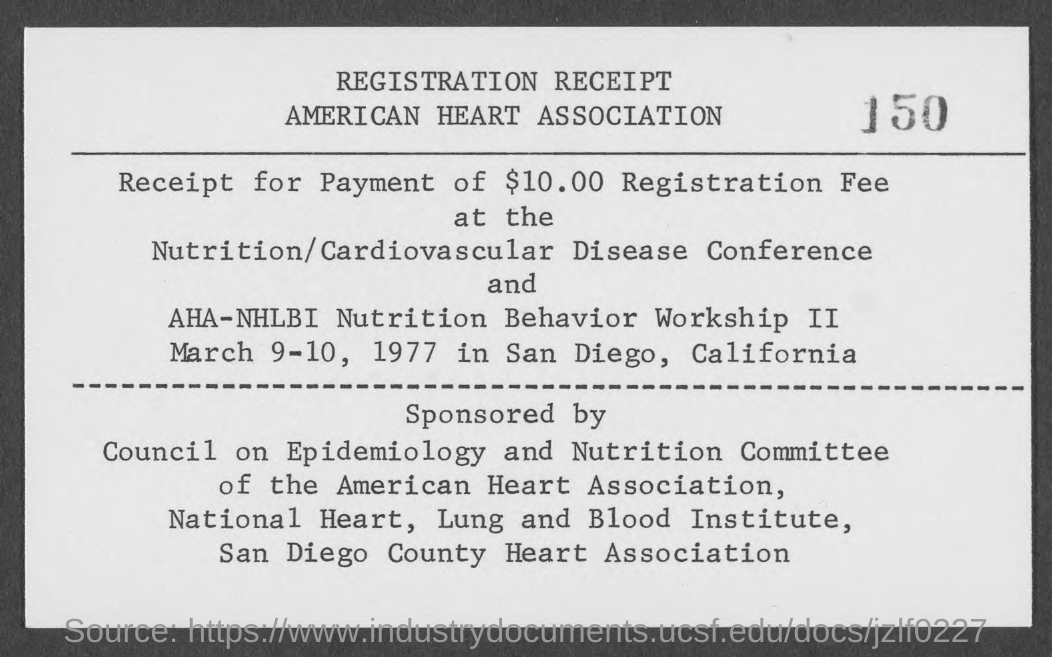What type of documentation is this?
Your answer should be very brief. Registration Receipt. How much Registration Fee was received?
Your response must be concise. $10.00. What is the conference about?
Offer a very short reply. Nutrition/Cardiovascular Disease. When is the program going to be held?
Keep it short and to the point. March 9-10, 1977. Where is the program going to be held?
Your answer should be very brief. San Diego, California. 